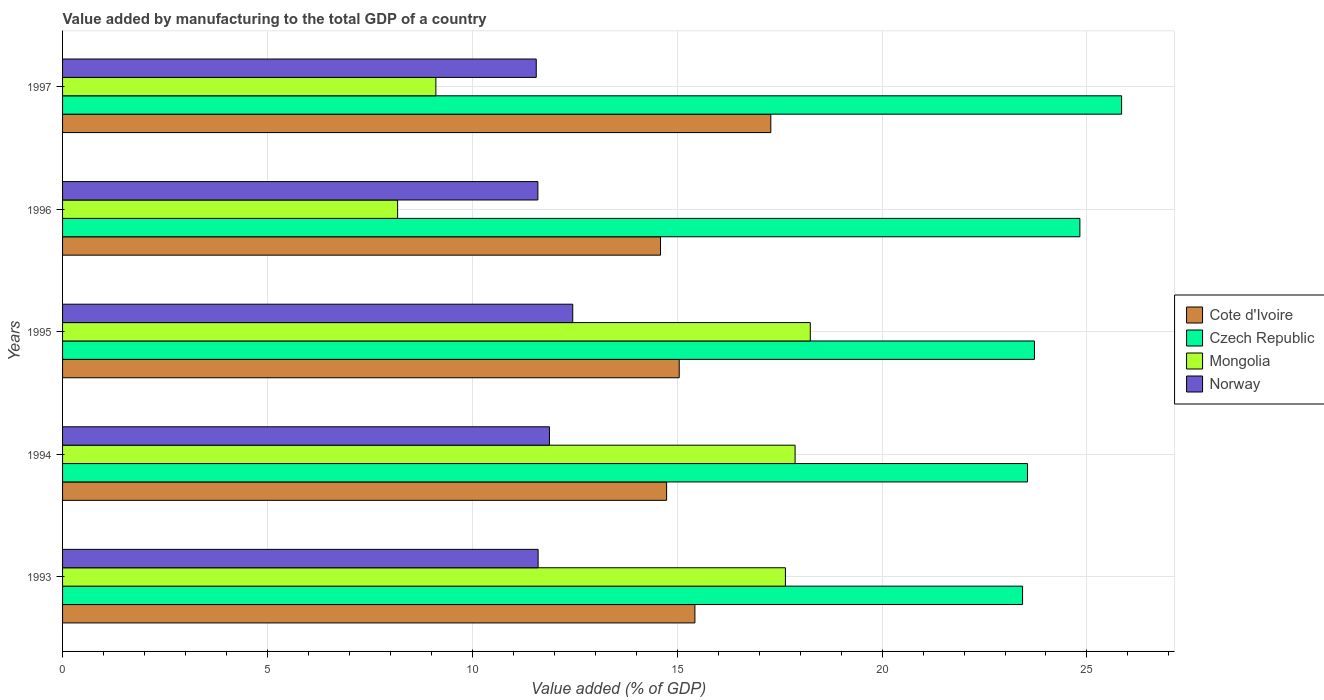How many different coloured bars are there?
Your answer should be very brief. 4. Are the number of bars per tick equal to the number of legend labels?
Ensure brevity in your answer.  Yes. How many bars are there on the 3rd tick from the top?
Give a very brief answer. 4. What is the label of the 1st group of bars from the top?
Your response must be concise. 1997. What is the value added by manufacturing to the total GDP in Norway in 1997?
Your response must be concise. 11.56. Across all years, what is the maximum value added by manufacturing to the total GDP in Cote d'Ivoire?
Provide a succinct answer. 17.28. Across all years, what is the minimum value added by manufacturing to the total GDP in Mongolia?
Make the answer very short. 8.18. What is the total value added by manufacturing to the total GDP in Czech Republic in the graph?
Provide a short and direct response. 121.37. What is the difference between the value added by manufacturing to the total GDP in Czech Republic in 1994 and that in 1995?
Provide a short and direct response. -0.17. What is the difference between the value added by manufacturing to the total GDP in Mongolia in 1993 and the value added by manufacturing to the total GDP in Czech Republic in 1994?
Ensure brevity in your answer.  -5.91. What is the average value added by manufacturing to the total GDP in Czech Republic per year?
Your response must be concise. 24.27. In the year 1993, what is the difference between the value added by manufacturing to the total GDP in Cote d'Ivoire and value added by manufacturing to the total GDP in Czech Republic?
Your answer should be compact. -8. What is the ratio of the value added by manufacturing to the total GDP in Czech Republic in 1993 to that in 1994?
Offer a very short reply. 0.99. Is the value added by manufacturing to the total GDP in Czech Republic in 1993 less than that in 1994?
Your answer should be compact. Yes. What is the difference between the highest and the second highest value added by manufacturing to the total GDP in Norway?
Give a very brief answer. 0.57. What is the difference between the highest and the lowest value added by manufacturing to the total GDP in Czech Republic?
Keep it short and to the point. 2.42. Is the sum of the value added by manufacturing to the total GDP in Cote d'Ivoire in 1994 and 1996 greater than the maximum value added by manufacturing to the total GDP in Norway across all years?
Provide a short and direct response. Yes. What does the 2nd bar from the bottom in 1993 represents?
Offer a very short reply. Czech Republic. Is it the case that in every year, the sum of the value added by manufacturing to the total GDP in Mongolia and value added by manufacturing to the total GDP in Norway is greater than the value added by manufacturing to the total GDP in Czech Republic?
Keep it short and to the point. No. How many bars are there?
Provide a succinct answer. 20. Are the values on the major ticks of X-axis written in scientific E-notation?
Ensure brevity in your answer.  No. Does the graph contain any zero values?
Your response must be concise. No. Does the graph contain grids?
Your response must be concise. Yes. How many legend labels are there?
Your answer should be compact. 4. How are the legend labels stacked?
Give a very brief answer. Vertical. What is the title of the graph?
Your response must be concise. Value added by manufacturing to the total GDP of a country. What is the label or title of the X-axis?
Provide a short and direct response. Value added (% of GDP). What is the Value added (% of GDP) in Cote d'Ivoire in 1993?
Provide a succinct answer. 15.43. What is the Value added (% of GDP) of Czech Republic in 1993?
Your answer should be compact. 23.43. What is the Value added (% of GDP) in Mongolia in 1993?
Offer a very short reply. 17.64. What is the Value added (% of GDP) in Norway in 1993?
Ensure brevity in your answer.  11.61. What is the Value added (% of GDP) of Cote d'Ivoire in 1994?
Offer a very short reply. 14.74. What is the Value added (% of GDP) in Czech Republic in 1994?
Provide a succinct answer. 23.55. What is the Value added (% of GDP) of Mongolia in 1994?
Your answer should be very brief. 17.88. What is the Value added (% of GDP) in Norway in 1994?
Offer a very short reply. 11.88. What is the Value added (% of GDP) of Cote d'Ivoire in 1995?
Your response must be concise. 15.05. What is the Value added (% of GDP) in Czech Republic in 1995?
Keep it short and to the point. 23.72. What is the Value added (% of GDP) in Mongolia in 1995?
Make the answer very short. 18.25. What is the Value added (% of GDP) in Norway in 1995?
Keep it short and to the point. 12.45. What is the Value added (% of GDP) in Cote d'Ivoire in 1996?
Keep it short and to the point. 14.59. What is the Value added (% of GDP) of Czech Republic in 1996?
Offer a terse response. 24.83. What is the Value added (% of GDP) of Mongolia in 1996?
Offer a very short reply. 8.18. What is the Value added (% of GDP) of Norway in 1996?
Give a very brief answer. 11.6. What is the Value added (% of GDP) in Cote d'Ivoire in 1997?
Make the answer very short. 17.28. What is the Value added (% of GDP) of Czech Republic in 1997?
Provide a short and direct response. 25.85. What is the Value added (% of GDP) of Mongolia in 1997?
Give a very brief answer. 9.11. What is the Value added (% of GDP) of Norway in 1997?
Your answer should be compact. 11.56. Across all years, what is the maximum Value added (% of GDP) in Cote d'Ivoire?
Offer a very short reply. 17.28. Across all years, what is the maximum Value added (% of GDP) of Czech Republic?
Your answer should be very brief. 25.85. Across all years, what is the maximum Value added (% of GDP) in Mongolia?
Offer a terse response. 18.25. Across all years, what is the maximum Value added (% of GDP) in Norway?
Provide a succinct answer. 12.45. Across all years, what is the minimum Value added (% of GDP) of Cote d'Ivoire?
Provide a succinct answer. 14.59. Across all years, what is the minimum Value added (% of GDP) of Czech Republic?
Give a very brief answer. 23.43. Across all years, what is the minimum Value added (% of GDP) in Mongolia?
Keep it short and to the point. 8.18. Across all years, what is the minimum Value added (% of GDP) in Norway?
Make the answer very short. 11.56. What is the total Value added (% of GDP) of Cote d'Ivoire in the graph?
Your answer should be very brief. 77.1. What is the total Value added (% of GDP) of Czech Republic in the graph?
Your answer should be very brief. 121.37. What is the total Value added (% of GDP) in Mongolia in the graph?
Provide a short and direct response. 71.05. What is the total Value added (% of GDP) in Norway in the graph?
Give a very brief answer. 59.1. What is the difference between the Value added (% of GDP) in Cote d'Ivoire in 1993 and that in 1994?
Your response must be concise. 0.69. What is the difference between the Value added (% of GDP) of Czech Republic in 1993 and that in 1994?
Provide a short and direct response. -0.12. What is the difference between the Value added (% of GDP) in Mongolia in 1993 and that in 1994?
Your answer should be very brief. -0.24. What is the difference between the Value added (% of GDP) in Norway in 1993 and that in 1994?
Offer a terse response. -0.28. What is the difference between the Value added (% of GDP) of Cote d'Ivoire in 1993 and that in 1995?
Ensure brevity in your answer.  0.38. What is the difference between the Value added (% of GDP) in Czech Republic in 1993 and that in 1995?
Offer a very short reply. -0.29. What is the difference between the Value added (% of GDP) of Mongolia in 1993 and that in 1995?
Your answer should be very brief. -0.61. What is the difference between the Value added (% of GDP) of Norway in 1993 and that in 1995?
Ensure brevity in your answer.  -0.84. What is the difference between the Value added (% of GDP) of Cote d'Ivoire in 1993 and that in 1996?
Give a very brief answer. 0.84. What is the difference between the Value added (% of GDP) in Czech Republic in 1993 and that in 1996?
Keep it short and to the point. -1.4. What is the difference between the Value added (% of GDP) of Mongolia in 1993 and that in 1996?
Offer a very short reply. 9.46. What is the difference between the Value added (% of GDP) in Norway in 1993 and that in 1996?
Keep it short and to the point. 0.01. What is the difference between the Value added (% of GDP) in Cote d'Ivoire in 1993 and that in 1997?
Your response must be concise. -1.85. What is the difference between the Value added (% of GDP) in Czech Republic in 1993 and that in 1997?
Make the answer very short. -2.42. What is the difference between the Value added (% of GDP) of Mongolia in 1993 and that in 1997?
Provide a succinct answer. 8.53. What is the difference between the Value added (% of GDP) of Norway in 1993 and that in 1997?
Your answer should be compact. 0.05. What is the difference between the Value added (% of GDP) in Cote d'Ivoire in 1994 and that in 1995?
Your answer should be very brief. -0.31. What is the difference between the Value added (% of GDP) of Czech Republic in 1994 and that in 1995?
Your answer should be very brief. -0.17. What is the difference between the Value added (% of GDP) of Mongolia in 1994 and that in 1995?
Your answer should be very brief. -0.37. What is the difference between the Value added (% of GDP) in Norway in 1994 and that in 1995?
Ensure brevity in your answer.  -0.57. What is the difference between the Value added (% of GDP) of Cote d'Ivoire in 1994 and that in 1996?
Offer a very short reply. 0.15. What is the difference between the Value added (% of GDP) of Czech Republic in 1994 and that in 1996?
Ensure brevity in your answer.  -1.28. What is the difference between the Value added (% of GDP) in Mongolia in 1994 and that in 1996?
Offer a very short reply. 9.7. What is the difference between the Value added (% of GDP) in Norway in 1994 and that in 1996?
Make the answer very short. 0.28. What is the difference between the Value added (% of GDP) of Cote d'Ivoire in 1994 and that in 1997?
Your answer should be very brief. -2.54. What is the difference between the Value added (% of GDP) in Czech Republic in 1994 and that in 1997?
Offer a very short reply. -2.3. What is the difference between the Value added (% of GDP) of Mongolia in 1994 and that in 1997?
Keep it short and to the point. 8.77. What is the difference between the Value added (% of GDP) in Norway in 1994 and that in 1997?
Provide a succinct answer. 0.32. What is the difference between the Value added (% of GDP) of Cote d'Ivoire in 1995 and that in 1996?
Provide a succinct answer. 0.46. What is the difference between the Value added (% of GDP) in Czech Republic in 1995 and that in 1996?
Give a very brief answer. -1.11. What is the difference between the Value added (% of GDP) of Mongolia in 1995 and that in 1996?
Offer a terse response. 10.07. What is the difference between the Value added (% of GDP) in Norway in 1995 and that in 1996?
Your answer should be compact. 0.85. What is the difference between the Value added (% of GDP) of Cote d'Ivoire in 1995 and that in 1997?
Your response must be concise. -2.24. What is the difference between the Value added (% of GDP) of Czech Republic in 1995 and that in 1997?
Make the answer very short. -2.13. What is the difference between the Value added (% of GDP) of Mongolia in 1995 and that in 1997?
Give a very brief answer. 9.14. What is the difference between the Value added (% of GDP) of Norway in 1995 and that in 1997?
Offer a very short reply. 0.89. What is the difference between the Value added (% of GDP) in Cote d'Ivoire in 1996 and that in 1997?
Ensure brevity in your answer.  -2.69. What is the difference between the Value added (% of GDP) of Czech Republic in 1996 and that in 1997?
Your answer should be compact. -1.02. What is the difference between the Value added (% of GDP) in Mongolia in 1996 and that in 1997?
Your answer should be very brief. -0.93. What is the difference between the Value added (% of GDP) in Norway in 1996 and that in 1997?
Give a very brief answer. 0.04. What is the difference between the Value added (% of GDP) in Cote d'Ivoire in 1993 and the Value added (% of GDP) in Czech Republic in 1994?
Your response must be concise. -8.12. What is the difference between the Value added (% of GDP) in Cote d'Ivoire in 1993 and the Value added (% of GDP) in Mongolia in 1994?
Your response must be concise. -2.44. What is the difference between the Value added (% of GDP) in Cote d'Ivoire in 1993 and the Value added (% of GDP) in Norway in 1994?
Ensure brevity in your answer.  3.55. What is the difference between the Value added (% of GDP) of Czech Republic in 1993 and the Value added (% of GDP) of Mongolia in 1994?
Provide a succinct answer. 5.55. What is the difference between the Value added (% of GDP) of Czech Republic in 1993 and the Value added (% of GDP) of Norway in 1994?
Your response must be concise. 11.55. What is the difference between the Value added (% of GDP) in Mongolia in 1993 and the Value added (% of GDP) in Norway in 1994?
Provide a succinct answer. 5.76. What is the difference between the Value added (% of GDP) of Cote d'Ivoire in 1993 and the Value added (% of GDP) of Czech Republic in 1995?
Give a very brief answer. -8.29. What is the difference between the Value added (% of GDP) of Cote d'Ivoire in 1993 and the Value added (% of GDP) of Mongolia in 1995?
Keep it short and to the point. -2.82. What is the difference between the Value added (% of GDP) in Cote d'Ivoire in 1993 and the Value added (% of GDP) in Norway in 1995?
Your answer should be very brief. 2.98. What is the difference between the Value added (% of GDP) in Czech Republic in 1993 and the Value added (% of GDP) in Mongolia in 1995?
Your answer should be very brief. 5.18. What is the difference between the Value added (% of GDP) in Czech Republic in 1993 and the Value added (% of GDP) in Norway in 1995?
Provide a succinct answer. 10.98. What is the difference between the Value added (% of GDP) in Mongolia in 1993 and the Value added (% of GDP) in Norway in 1995?
Provide a short and direct response. 5.19. What is the difference between the Value added (% of GDP) in Cote d'Ivoire in 1993 and the Value added (% of GDP) in Czech Republic in 1996?
Offer a terse response. -9.4. What is the difference between the Value added (% of GDP) of Cote d'Ivoire in 1993 and the Value added (% of GDP) of Mongolia in 1996?
Ensure brevity in your answer.  7.26. What is the difference between the Value added (% of GDP) of Cote d'Ivoire in 1993 and the Value added (% of GDP) of Norway in 1996?
Offer a terse response. 3.83. What is the difference between the Value added (% of GDP) of Czech Republic in 1993 and the Value added (% of GDP) of Mongolia in 1996?
Offer a terse response. 15.25. What is the difference between the Value added (% of GDP) in Czech Republic in 1993 and the Value added (% of GDP) in Norway in 1996?
Provide a succinct answer. 11.83. What is the difference between the Value added (% of GDP) of Mongolia in 1993 and the Value added (% of GDP) of Norway in 1996?
Your answer should be very brief. 6.04. What is the difference between the Value added (% of GDP) of Cote d'Ivoire in 1993 and the Value added (% of GDP) of Czech Republic in 1997?
Offer a very short reply. -10.41. What is the difference between the Value added (% of GDP) in Cote d'Ivoire in 1993 and the Value added (% of GDP) in Mongolia in 1997?
Keep it short and to the point. 6.32. What is the difference between the Value added (% of GDP) of Cote d'Ivoire in 1993 and the Value added (% of GDP) of Norway in 1997?
Your answer should be very brief. 3.87. What is the difference between the Value added (% of GDP) of Czech Republic in 1993 and the Value added (% of GDP) of Mongolia in 1997?
Your response must be concise. 14.32. What is the difference between the Value added (% of GDP) of Czech Republic in 1993 and the Value added (% of GDP) of Norway in 1997?
Give a very brief answer. 11.87. What is the difference between the Value added (% of GDP) of Mongolia in 1993 and the Value added (% of GDP) of Norway in 1997?
Provide a short and direct response. 6.08. What is the difference between the Value added (% of GDP) of Cote d'Ivoire in 1994 and the Value added (% of GDP) of Czech Republic in 1995?
Your answer should be very brief. -8.98. What is the difference between the Value added (% of GDP) in Cote d'Ivoire in 1994 and the Value added (% of GDP) in Mongolia in 1995?
Offer a terse response. -3.51. What is the difference between the Value added (% of GDP) of Cote d'Ivoire in 1994 and the Value added (% of GDP) of Norway in 1995?
Your answer should be very brief. 2.29. What is the difference between the Value added (% of GDP) of Czech Republic in 1994 and the Value added (% of GDP) of Mongolia in 1995?
Provide a succinct answer. 5.3. What is the difference between the Value added (% of GDP) in Czech Republic in 1994 and the Value added (% of GDP) in Norway in 1995?
Provide a short and direct response. 11.1. What is the difference between the Value added (% of GDP) of Mongolia in 1994 and the Value added (% of GDP) of Norway in 1995?
Provide a succinct answer. 5.43. What is the difference between the Value added (% of GDP) in Cote d'Ivoire in 1994 and the Value added (% of GDP) in Czech Republic in 1996?
Ensure brevity in your answer.  -10.09. What is the difference between the Value added (% of GDP) of Cote d'Ivoire in 1994 and the Value added (% of GDP) of Mongolia in 1996?
Your response must be concise. 6.57. What is the difference between the Value added (% of GDP) in Cote d'Ivoire in 1994 and the Value added (% of GDP) in Norway in 1996?
Your answer should be compact. 3.14. What is the difference between the Value added (% of GDP) in Czech Republic in 1994 and the Value added (% of GDP) in Mongolia in 1996?
Provide a succinct answer. 15.37. What is the difference between the Value added (% of GDP) in Czech Republic in 1994 and the Value added (% of GDP) in Norway in 1996?
Your answer should be compact. 11.95. What is the difference between the Value added (% of GDP) of Mongolia in 1994 and the Value added (% of GDP) of Norway in 1996?
Your response must be concise. 6.28. What is the difference between the Value added (% of GDP) of Cote d'Ivoire in 1994 and the Value added (% of GDP) of Czech Republic in 1997?
Make the answer very short. -11.1. What is the difference between the Value added (% of GDP) of Cote d'Ivoire in 1994 and the Value added (% of GDP) of Mongolia in 1997?
Give a very brief answer. 5.63. What is the difference between the Value added (% of GDP) of Cote d'Ivoire in 1994 and the Value added (% of GDP) of Norway in 1997?
Your answer should be compact. 3.18. What is the difference between the Value added (% of GDP) of Czech Republic in 1994 and the Value added (% of GDP) of Mongolia in 1997?
Provide a succinct answer. 14.44. What is the difference between the Value added (% of GDP) in Czech Republic in 1994 and the Value added (% of GDP) in Norway in 1997?
Your answer should be compact. 11.99. What is the difference between the Value added (% of GDP) in Mongolia in 1994 and the Value added (% of GDP) in Norway in 1997?
Offer a very short reply. 6.32. What is the difference between the Value added (% of GDP) of Cote d'Ivoire in 1995 and the Value added (% of GDP) of Czech Republic in 1996?
Ensure brevity in your answer.  -9.78. What is the difference between the Value added (% of GDP) of Cote d'Ivoire in 1995 and the Value added (% of GDP) of Mongolia in 1996?
Offer a terse response. 6.87. What is the difference between the Value added (% of GDP) of Cote d'Ivoire in 1995 and the Value added (% of GDP) of Norway in 1996?
Keep it short and to the point. 3.45. What is the difference between the Value added (% of GDP) of Czech Republic in 1995 and the Value added (% of GDP) of Mongolia in 1996?
Ensure brevity in your answer.  15.54. What is the difference between the Value added (% of GDP) in Czech Republic in 1995 and the Value added (% of GDP) in Norway in 1996?
Your response must be concise. 12.12. What is the difference between the Value added (% of GDP) in Mongolia in 1995 and the Value added (% of GDP) in Norway in 1996?
Give a very brief answer. 6.65. What is the difference between the Value added (% of GDP) in Cote d'Ivoire in 1995 and the Value added (% of GDP) in Czech Republic in 1997?
Make the answer very short. -10.8. What is the difference between the Value added (% of GDP) in Cote d'Ivoire in 1995 and the Value added (% of GDP) in Mongolia in 1997?
Your response must be concise. 5.94. What is the difference between the Value added (% of GDP) of Cote d'Ivoire in 1995 and the Value added (% of GDP) of Norway in 1997?
Your response must be concise. 3.49. What is the difference between the Value added (% of GDP) of Czech Republic in 1995 and the Value added (% of GDP) of Mongolia in 1997?
Your answer should be compact. 14.61. What is the difference between the Value added (% of GDP) in Czech Republic in 1995 and the Value added (% of GDP) in Norway in 1997?
Your answer should be compact. 12.16. What is the difference between the Value added (% of GDP) of Mongolia in 1995 and the Value added (% of GDP) of Norway in 1997?
Your answer should be compact. 6.69. What is the difference between the Value added (% of GDP) of Cote d'Ivoire in 1996 and the Value added (% of GDP) of Czech Republic in 1997?
Provide a succinct answer. -11.25. What is the difference between the Value added (% of GDP) in Cote d'Ivoire in 1996 and the Value added (% of GDP) in Mongolia in 1997?
Offer a very short reply. 5.48. What is the difference between the Value added (% of GDP) in Cote d'Ivoire in 1996 and the Value added (% of GDP) in Norway in 1997?
Your answer should be compact. 3.03. What is the difference between the Value added (% of GDP) of Czech Republic in 1996 and the Value added (% of GDP) of Mongolia in 1997?
Your answer should be compact. 15.72. What is the difference between the Value added (% of GDP) in Czech Republic in 1996 and the Value added (% of GDP) in Norway in 1997?
Ensure brevity in your answer.  13.27. What is the difference between the Value added (% of GDP) of Mongolia in 1996 and the Value added (% of GDP) of Norway in 1997?
Offer a very short reply. -3.38. What is the average Value added (% of GDP) in Cote d'Ivoire per year?
Offer a very short reply. 15.42. What is the average Value added (% of GDP) in Czech Republic per year?
Offer a very short reply. 24.27. What is the average Value added (% of GDP) of Mongolia per year?
Give a very brief answer. 14.21. What is the average Value added (% of GDP) in Norway per year?
Your answer should be very brief. 11.82. In the year 1993, what is the difference between the Value added (% of GDP) in Cote d'Ivoire and Value added (% of GDP) in Czech Republic?
Give a very brief answer. -8. In the year 1993, what is the difference between the Value added (% of GDP) in Cote d'Ivoire and Value added (% of GDP) in Mongolia?
Give a very brief answer. -2.21. In the year 1993, what is the difference between the Value added (% of GDP) in Cote d'Ivoire and Value added (% of GDP) in Norway?
Keep it short and to the point. 3.83. In the year 1993, what is the difference between the Value added (% of GDP) of Czech Republic and Value added (% of GDP) of Mongolia?
Your response must be concise. 5.79. In the year 1993, what is the difference between the Value added (% of GDP) in Czech Republic and Value added (% of GDP) in Norway?
Provide a short and direct response. 11.82. In the year 1993, what is the difference between the Value added (% of GDP) in Mongolia and Value added (% of GDP) in Norway?
Keep it short and to the point. 6.04. In the year 1994, what is the difference between the Value added (% of GDP) in Cote d'Ivoire and Value added (% of GDP) in Czech Republic?
Provide a succinct answer. -8.81. In the year 1994, what is the difference between the Value added (% of GDP) of Cote d'Ivoire and Value added (% of GDP) of Mongolia?
Ensure brevity in your answer.  -3.14. In the year 1994, what is the difference between the Value added (% of GDP) of Cote d'Ivoire and Value added (% of GDP) of Norway?
Your answer should be very brief. 2.86. In the year 1994, what is the difference between the Value added (% of GDP) of Czech Republic and Value added (% of GDP) of Mongolia?
Offer a very short reply. 5.67. In the year 1994, what is the difference between the Value added (% of GDP) of Czech Republic and Value added (% of GDP) of Norway?
Offer a terse response. 11.67. In the year 1994, what is the difference between the Value added (% of GDP) in Mongolia and Value added (% of GDP) in Norway?
Make the answer very short. 5.99. In the year 1995, what is the difference between the Value added (% of GDP) in Cote d'Ivoire and Value added (% of GDP) in Czech Republic?
Give a very brief answer. -8.67. In the year 1995, what is the difference between the Value added (% of GDP) of Cote d'Ivoire and Value added (% of GDP) of Mongolia?
Provide a succinct answer. -3.2. In the year 1995, what is the difference between the Value added (% of GDP) in Cote d'Ivoire and Value added (% of GDP) in Norway?
Offer a very short reply. 2.6. In the year 1995, what is the difference between the Value added (% of GDP) in Czech Republic and Value added (% of GDP) in Mongolia?
Your response must be concise. 5.47. In the year 1995, what is the difference between the Value added (% of GDP) of Czech Republic and Value added (% of GDP) of Norway?
Provide a succinct answer. 11.27. In the year 1995, what is the difference between the Value added (% of GDP) in Mongolia and Value added (% of GDP) in Norway?
Give a very brief answer. 5.8. In the year 1996, what is the difference between the Value added (% of GDP) of Cote d'Ivoire and Value added (% of GDP) of Czech Republic?
Offer a terse response. -10.23. In the year 1996, what is the difference between the Value added (% of GDP) of Cote d'Ivoire and Value added (% of GDP) of Mongolia?
Provide a succinct answer. 6.42. In the year 1996, what is the difference between the Value added (% of GDP) in Cote d'Ivoire and Value added (% of GDP) in Norway?
Keep it short and to the point. 2.99. In the year 1996, what is the difference between the Value added (% of GDP) of Czech Republic and Value added (% of GDP) of Mongolia?
Keep it short and to the point. 16.65. In the year 1996, what is the difference between the Value added (% of GDP) in Czech Republic and Value added (% of GDP) in Norway?
Make the answer very short. 13.23. In the year 1996, what is the difference between the Value added (% of GDP) of Mongolia and Value added (% of GDP) of Norway?
Your answer should be compact. -3.42. In the year 1997, what is the difference between the Value added (% of GDP) of Cote d'Ivoire and Value added (% of GDP) of Czech Republic?
Make the answer very short. -8.56. In the year 1997, what is the difference between the Value added (% of GDP) of Cote d'Ivoire and Value added (% of GDP) of Mongolia?
Your response must be concise. 8.17. In the year 1997, what is the difference between the Value added (% of GDP) of Cote d'Ivoire and Value added (% of GDP) of Norway?
Offer a very short reply. 5.72. In the year 1997, what is the difference between the Value added (% of GDP) of Czech Republic and Value added (% of GDP) of Mongolia?
Give a very brief answer. 16.74. In the year 1997, what is the difference between the Value added (% of GDP) of Czech Republic and Value added (% of GDP) of Norway?
Make the answer very short. 14.29. In the year 1997, what is the difference between the Value added (% of GDP) in Mongolia and Value added (% of GDP) in Norway?
Offer a terse response. -2.45. What is the ratio of the Value added (% of GDP) in Cote d'Ivoire in 1993 to that in 1994?
Make the answer very short. 1.05. What is the ratio of the Value added (% of GDP) in Czech Republic in 1993 to that in 1994?
Keep it short and to the point. 0.99. What is the ratio of the Value added (% of GDP) in Mongolia in 1993 to that in 1994?
Your response must be concise. 0.99. What is the ratio of the Value added (% of GDP) of Norway in 1993 to that in 1994?
Your answer should be very brief. 0.98. What is the ratio of the Value added (% of GDP) of Cote d'Ivoire in 1993 to that in 1995?
Keep it short and to the point. 1.03. What is the ratio of the Value added (% of GDP) of Czech Republic in 1993 to that in 1995?
Provide a succinct answer. 0.99. What is the ratio of the Value added (% of GDP) in Mongolia in 1993 to that in 1995?
Your response must be concise. 0.97. What is the ratio of the Value added (% of GDP) of Norway in 1993 to that in 1995?
Give a very brief answer. 0.93. What is the ratio of the Value added (% of GDP) in Cote d'Ivoire in 1993 to that in 1996?
Your response must be concise. 1.06. What is the ratio of the Value added (% of GDP) of Czech Republic in 1993 to that in 1996?
Provide a short and direct response. 0.94. What is the ratio of the Value added (% of GDP) of Mongolia in 1993 to that in 1996?
Ensure brevity in your answer.  2.16. What is the ratio of the Value added (% of GDP) in Cote d'Ivoire in 1993 to that in 1997?
Provide a succinct answer. 0.89. What is the ratio of the Value added (% of GDP) in Czech Republic in 1993 to that in 1997?
Make the answer very short. 0.91. What is the ratio of the Value added (% of GDP) of Mongolia in 1993 to that in 1997?
Offer a very short reply. 1.94. What is the ratio of the Value added (% of GDP) in Cote d'Ivoire in 1994 to that in 1995?
Offer a very short reply. 0.98. What is the ratio of the Value added (% of GDP) of Mongolia in 1994 to that in 1995?
Your answer should be compact. 0.98. What is the ratio of the Value added (% of GDP) in Norway in 1994 to that in 1995?
Your answer should be very brief. 0.95. What is the ratio of the Value added (% of GDP) of Cote d'Ivoire in 1994 to that in 1996?
Offer a terse response. 1.01. What is the ratio of the Value added (% of GDP) of Czech Republic in 1994 to that in 1996?
Your answer should be compact. 0.95. What is the ratio of the Value added (% of GDP) of Mongolia in 1994 to that in 1996?
Give a very brief answer. 2.19. What is the ratio of the Value added (% of GDP) in Norway in 1994 to that in 1996?
Your answer should be compact. 1.02. What is the ratio of the Value added (% of GDP) in Cote d'Ivoire in 1994 to that in 1997?
Your response must be concise. 0.85. What is the ratio of the Value added (% of GDP) in Czech Republic in 1994 to that in 1997?
Ensure brevity in your answer.  0.91. What is the ratio of the Value added (% of GDP) in Mongolia in 1994 to that in 1997?
Provide a succinct answer. 1.96. What is the ratio of the Value added (% of GDP) in Norway in 1994 to that in 1997?
Make the answer very short. 1.03. What is the ratio of the Value added (% of GDP) of Cote d'Ivoire in 1995 to that in 1996?
Your response must be concise. 1.03. What is the ratio of the Value added (% of GDP) of Czech Republic in 1995 to that in 1996?
Give a very brief answer. 0.96. What is the ratio of the Value added (% of GDP) of Mongolia in 1995 to that in 1996?
Your answer should be very brief. 2.23. What is the ratio of the Value added (% of GDP) of Norway in 1995 to that in 1996?
Offer a very short reply. 1.07. What is the ratio of the Value added (% of GDP) in Cote d'Ivoire in 1995 to that in 1997?
Ensure brevity in your answer.  0.87. What is the ratio of the Value added (% of GDP) of Czech Republic in 1995 to that in 1997?
Your answer should be compact. 0.92. What is the ratio of the Value added (% of GDP) of Mongolia in 1995 to that in 1997?
Offer a very short reply. 2. What is the ratio of the Value added (% of GDP) of Norway in 1995 to that in 1997?
Provide a succinct answer. 1.08. What is the ratio of the Value added (% of GDP) in Cote d'Ivoire in 1996 to that in 1997?
Provide a short and direct response. 0.84. What is the ratio of the Value added (% of GDP) of Czech Republic in 1996 to that in 1997?
Provide a succinct answer. 0.96. What is the ratio of the Value added (% of GDP) of Mongolia in 1996 to that in 1997?
Your response must be concise. 0.9. What is the ratio of the Value added (% of GDP) of Norway in 1996 to that in 1997?
Give a very brief answer. 1. What is the difference between the highest and the second highest Value added (% of GDP) in Cote d'Ivoire?
Ensure brevity in your answer.  1.85. What is the difference between the highest and the second highest Value added (% of GDP) of Czech Republic?
Offer a terse response. 1.02. What is the difference between the highest and the second highest Value added (% of GDP) of Mongolia?
Your response must be concise. 0.37. What is the difference between the highest and the second highest Value added (% of GDP) in Norway?
Ensure brevity in your answer.  0.57. What is the difference between the highest and the lowest Value added (% of GDP) of Cote d'Ivoire?
Make the answer very short. 2.69. What is the difference between the highest and the lowest Value added (% of GDP) in Czech Republic?
Your answer should be very brief. 2.42. What is the difference between the highest and the lowest Value added (% of GDP) of Mongolia?
Give a very brief answer. 10.07. What is the difference between the highest and the lowest Value added (% of GDP) in Norway?
Your answer should be compact. 0.89. 